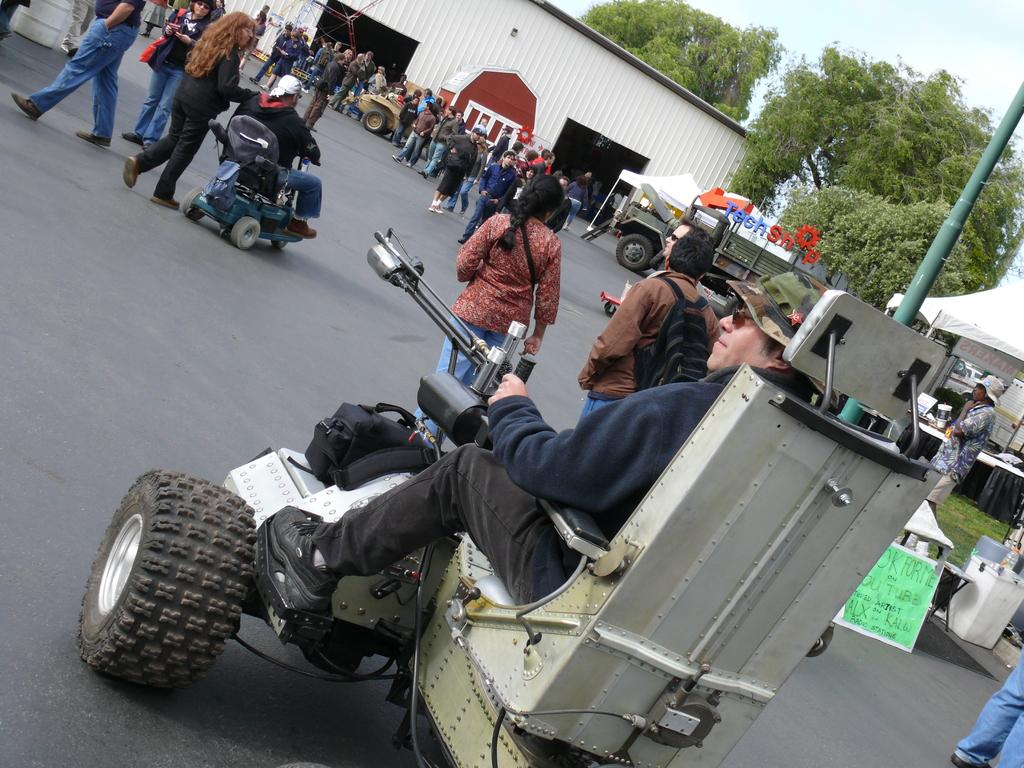What are the persons in the image doing? There are persons riding vehicles and walking on the road in the image. What can be seen at the top of the image? There is a shirt visible at the top of the image. What type of vegetation is on the right side of the image? There are trees on the right side of the image. Can you tell me how many strangers are learning to play the guitar in the image? There is no mention of strangers or guitar playing in the image; it features persons riding vehicles and walking on the road. 